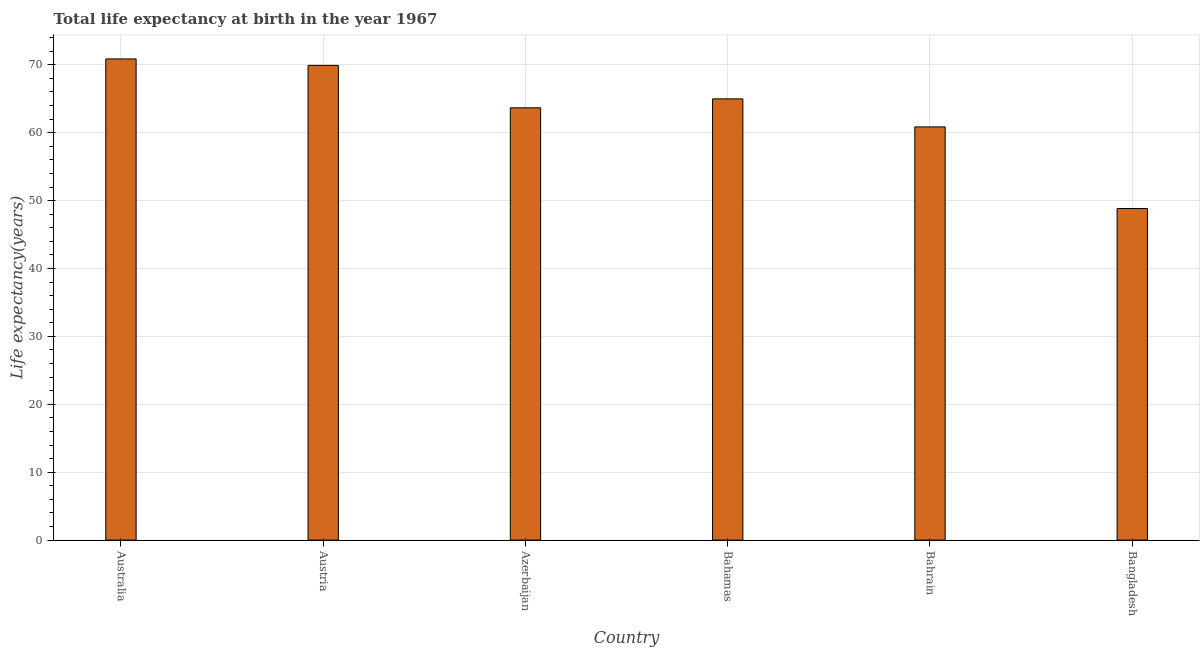Does the graph contain grids?
Your response must be concise. Yes. What is the title of the graph?
Ensure brevity in your answer.  Total life expectancy at birth in the year 1967. What is the label or title of the X-axis?
Your answer should be very brief. Country. What is the label or title of the Y-axis?
Your answer should be very brief. Life expectancy(years). What is the life expectancy at birth in Bangladesh?
Offer a terse response. 48.84. Across all countries, what is the maximum life expectancy at birth?
Keep it short and to the point. 70.87. Across all countries, what is the minimum life expectancy at birth?
Your answer should be very brief. 48.84. What is the sum of the life expectancy at birth?
Provide a short and direct response. 379.14. What is the difference between the life expectancy at birth in Bahamas and Bangladesh?
Keep it short and to the point. 16.15. What is the average life expectancy at birth per country?
Your answer should be compact. 63.19. What is the median life expectancy at birth?
Provide a short and direct response. 64.33. What is the ratio of the life expectancy at birth in Australia to that in Bahrain?
Keep it short and to the point. 1.17. Is the life expectancy at birth in Bahamas less than that in Bangladesh?
Offer a very short reply. No. What is the difference between the highest and the second highest life expectancy at birth?
Keep it short and to the point. 0.95. What is the difference between the highest and the lowest life expectancy at birth?
Make the answer very short. 22.03. How many bars are there?
Provide a short and direct response. 6. Are all the bars in the graph horizontal?
Your response must be concise. No. What is the difference between two consecutive major ticks on the Y-axis?
Give a very brief answer. 10. What is the Life expectancy(years) in Australia?
Provide a succinct answer. 70.87. What is the Life expectancy(years) in Austria?
Give a very brief answer. 69.92. What is the Life expectancy(years) in Azerbaijan?
Keep it short and to the point. 63.67. What is the Life expectancy(years) in Bahamas?
Your response must be concise. 64.99. What is the Life expectancy(years) of Bahrain?
Ensure brevity in your answer.  60.86. What is the Life expectancy(years) of Bangladesh?
Ensure brevity in your answer.  48.84. What is the difference between the Life expectancy(years) in Australia and Austria?
Offer a very short reply. 0.95. What is the difference between the Life expectancy(years) in Australia and Azerbaijan?
Keep it short and to the point. 7.2. What is the difference between the Life expectancy(years) in Australia and Bahamas?
Offer a terse response. 5.88. What is the difference between the Life expectancy(years) in Australia and Bahrain?
Provide a succinct answer. 10.01. What is the difference between the Life expectancy(years) in Australia and Bangladesh?
Provide a succinct answer. 22.03. What is the difference between the Life expectancy(years) in Austria and Azerbaijan?
Your answer should be very brief. 6.25. What is the difference between the Life expectancy(years) in Austria and Bahamas?
Make the answer very short. 4.93. What is the difference between the Life expectancy(years) in Austria and Bahrain?
Offer a very short reply. 9.06. What is the difference between the Life expectancy(years) in Austria and Bangladesh?
Provide a succinct answer. 21.08. What is the difference between the Life expectancy(years) in Azerbaijan and Bahamas?
Your response must be concise. -1.32. What is the difference between the Life expectancy(years) in Azerbaijan and Bahrain?
Your response must be concise. 2.81. What is the difference between the Life expectancy(years) in Azerbaijan and Bangladesh?
Keep it short and to the point. 14.83. What is the difference between the Life expectancy(years) in Bahamas and Bahrain?
Ensure brevity in your answer.  4.13. What is the difference between the Life expectancy(years) in Bahamas and Bangladesh?
Your answer should be very brief. 16.15. What is the difference between the Life expectancy(years) in Bahrain and Bangladesh?
Ensure brevity in your answer.  12.02. What is the ratio of the Life expectancy(years) in Australia to that in Azerbaijan?
Offer a terse response. 1.11. What is the ratio of the Life expectancy(years) in Australia to that in Bahamas?
Your answer should be compact. 1.09. What is the ratio of the Life expectancy(years) in Australia to that in Bahrain?
Provide a short and direct response. 1.17. What is the ratio of the Life expectancy(years) in Australia to that in Bangladesh?
Ensure brevity in your answer.  1.45. What is the ratio of the Life expectancy(years) in Austria to that in Azerbaijan?
Your answer should be very brief. 1.1. What is the ratio of the Life expectancy(years) in Austria to that in Bahamas?
Your response must be concise. 1.08. What is the ratio of the Life expectancy(years) in Austria to that in Bahrain?
Your answer should be very brief. 1.15. What is the ratio of the Life expectancy(years) in Austria to that in Bangladesh?
Make the answer very short. 1.43. What is the ratio of the Life expectancy(years) in Azerbaijan to that in Bahamas?
Ensure brevity in your answer.  0.98. What is the ratio of the Life expectancy(years) in Azerbaijan to that in Bahrain?
Make the answer very short. 1.05. What is the ratio of the Life expectancy(years) in Azerbaijan to that in Bangladesh?
Provide a short and direct response. 1.3. What is the ratio of the Life expectancy(years) in Bahamas to that in Bahrain?
Your answer should be very brief. 1.07. What is the ratio of the Life expectancy(years) in Bahamas to that in Bangladesh?
Your answer should be very brief. 1.33. What is the ratio of the Life expectancy(years) in Bahrain to that in Bangladesh?
Your answer should be very brief. 1.25. 